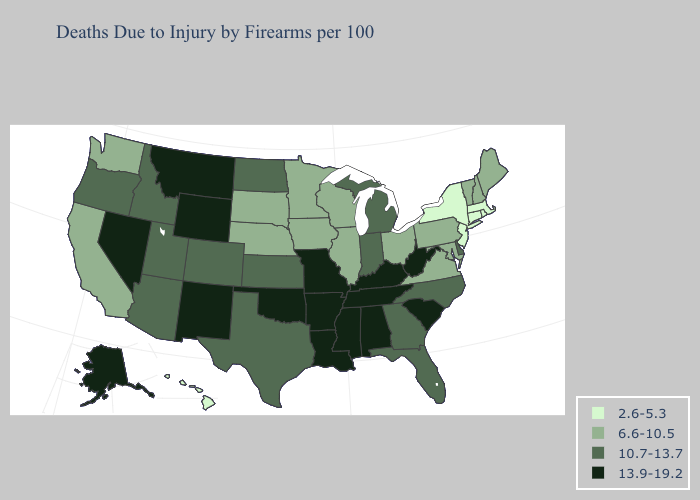What is the value of Hawaii?
Keep it brief. 2.6-5.3. Does the map have missing data?
Short answer required. No. Among the states that border Arkansas , does Texas have the highest value?
Short answer required. No. What is the lowest value in states that border Virginia?
Write a very short answer. 6.6-10.5. Is the legend a continuous bar?
Write a very short answer. No. What is the highest value in the USA?
Give a very brief answer. 13.9-19.2. What is the value of Washington?
Short answer required. 6.6-10.5. What is the value of North Dakota?
Answer briefly. 10.7-13.7. Which states have the lowest value in the USA?
Answer briefly. Connecticut, Hawaii, Massachusetts, New Jersey, New York, Rhode Island. Among the states that border Kentucky , does Illinois have the lowest value?
Write a very short answer. Yes. Does Indiana have a lower value than Nevada?
Answer briefly. Yes. Among the states that border Rhode Island , which have the highest value?
Give a very brief answer. Connecticut, Massachusetts. How many symbols are there in the legend?
Quick response, please. 4. Among the states that border Wyoming , which have the lowest value?
Answer briefly. Nebraska, South Dakota. What is the lowest value in the Northeast?
Short answer required. 2.6-5.3. 